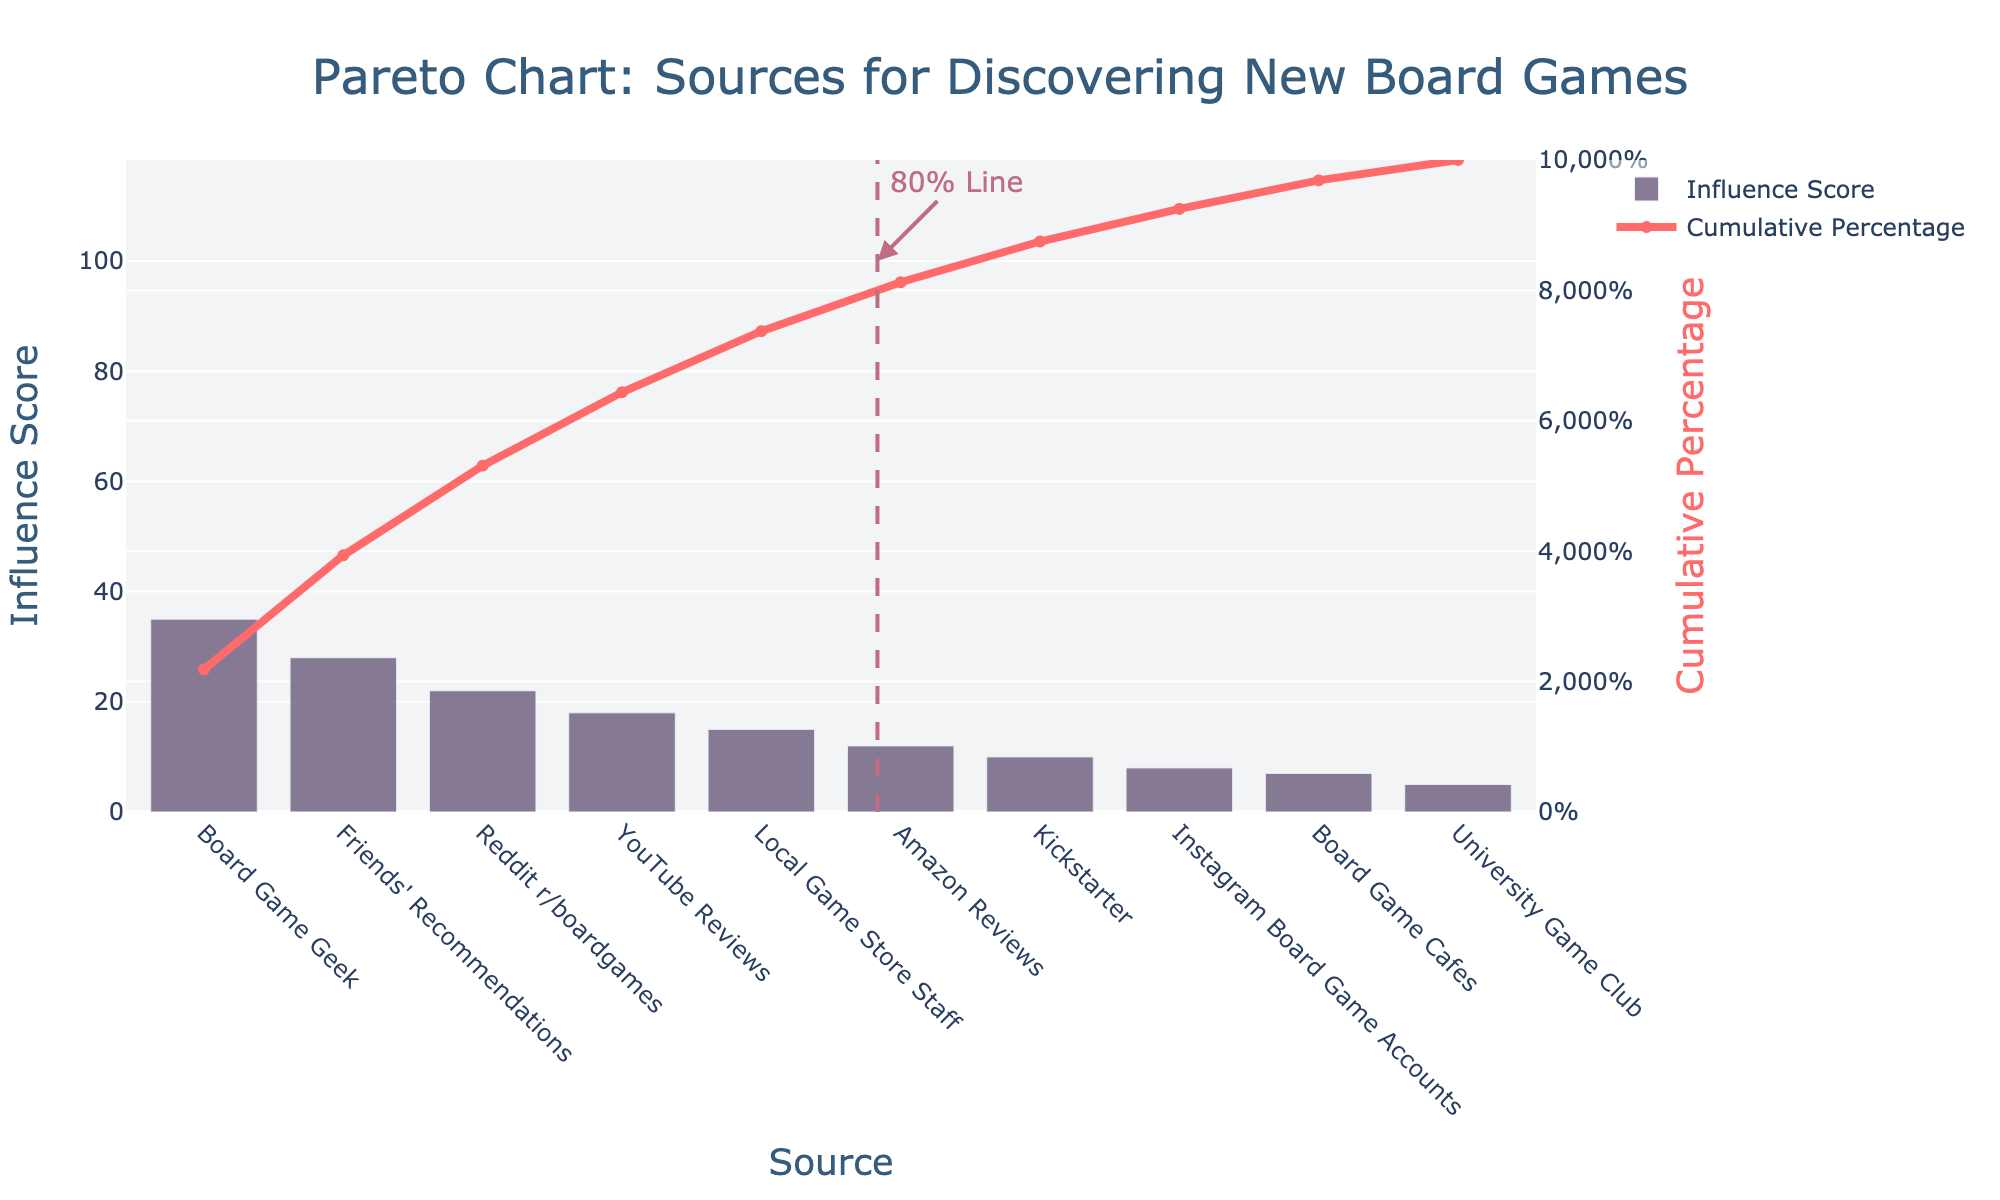What is the title of the figure? The title is displayed at the top center of the figure. It reads "Pareto Chart: Sources for Discovering New Board Games."
Answer: Pareto Chart: Sources for Discovering New Board Games Which source has the highest influence score? The highest bar in the bar chart represents the source with the highest influence score. The bar labeled "Board Game Geek" has the highest influence score.
Answer: Board Game Geek How many sources contribute to 80% of the cumulative influence? The cumulative percentage line intersects the 80% mark, which is represented by a dashed line. Counting the bars to this intersection, we see 4 sources: "Board Game Geek," "Friends' Recommendations," "Reddit r/boardgames," and "YouTube Reviews."
Answer: 4 What is the cumulative percentage after the third source? The cumulative percentage line is used to find this value. At "Reddit r/boardgames," which is the third source, the cumulative percentage reaches 63.16%.
Answer: 63.16% What is the influence score of Instagram Board Game Accounts? Locate the bar corresponding to "Instagram Board Game Accounts" and refer to its height along the y-axis for the influence score. It reads 8.
Answer: 8 Which source has the least influence on purchase decisions? The shortest bar, which represents "University Game Club," indicates the source with the least influence score.
Answer: University Game Club Which source's influence score is directly in the middle of the ranking? To find the median source, locate the source that lies in the middle of the 10 sources listed. The 5th source is "Local Game Store Staff," with an influence score of 15.
Answer: Local Game Store Staff How does the cumulative percentage change from "Amazon Reviews" to "Kickstarter"? Identify the cumulative percentage at "Amazon Reviews" and "Kickstarter" on the cumulative line. "Amazon Reviews" reaches about 82.46%, and "Kickstarter" reaches about 86.96%. The difference is roughly 4.5%.
Answer: 4.5% Compare the influence score of "YouTube Reviews" and "Reddit r/boardgames." Locate the heights of the bars for "YouTube Reviews" (18) and "Reddit r/boardgames" (22). "Reddit r/boardgames" has a higher influence score by 4 points.
Answer: Reddit r/boardgames by 4 By how much does "Friends' Recommendations" exceed "University Game Club" in influence score? Subtract the influence score of "University Game Club" (5) from "Friends' Recommendations" (28). The result is 23.
Answer: 23 